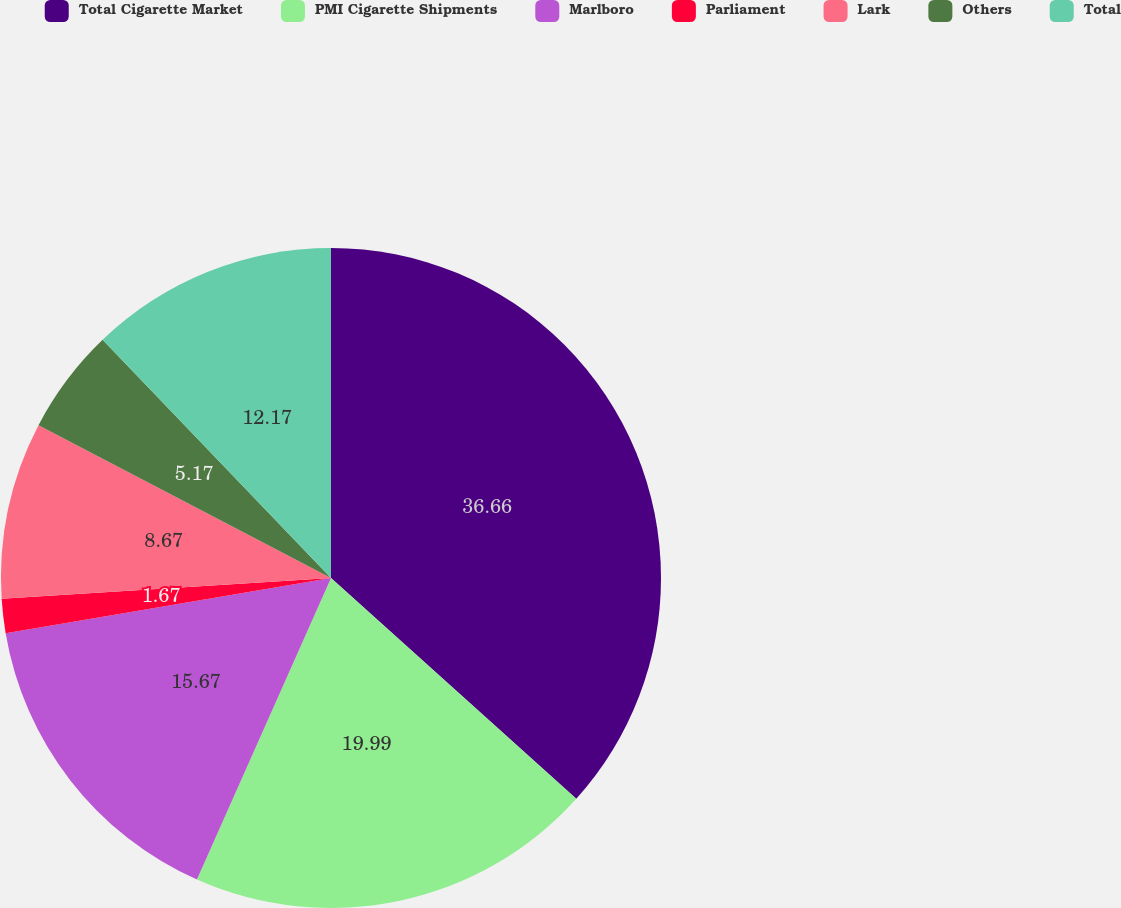<chart> <loc_0><loc_0><loc_500><loc_500><pie_chart><fcel>Total Cigarette Market<fcel>PMI Cigarette Shipments<fcel>Marlboro<fcel>Parliament<fcel>Lark<fcel>Others<fcel>Total<nl><fcel>36.67%<fcel>20.0%<fcel>15.67%<fcel>1.67%<fcel>8.67%<fcel>5.17%<fcel>12.17%<nl></chart> 